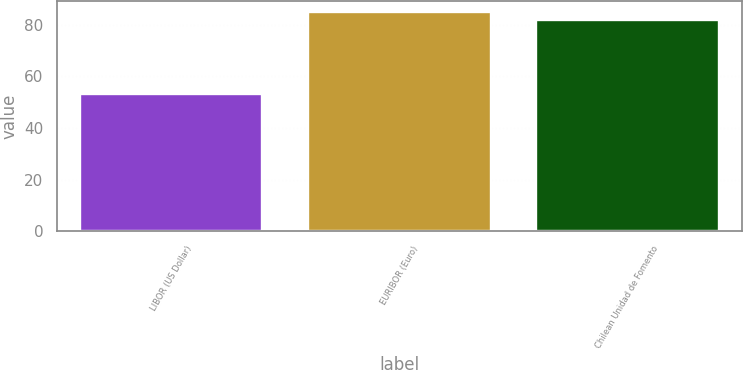<chart> <loc_0><loc_0><loc_500><loc_500><bar_chart><fcel>LIBOR (US Dollar)<fcel>EURIBOR (Euro)<fcel>Chilean Unidad de Fomento<nl><fcel>53<fcel>85<fcel>82<nl></chart> 